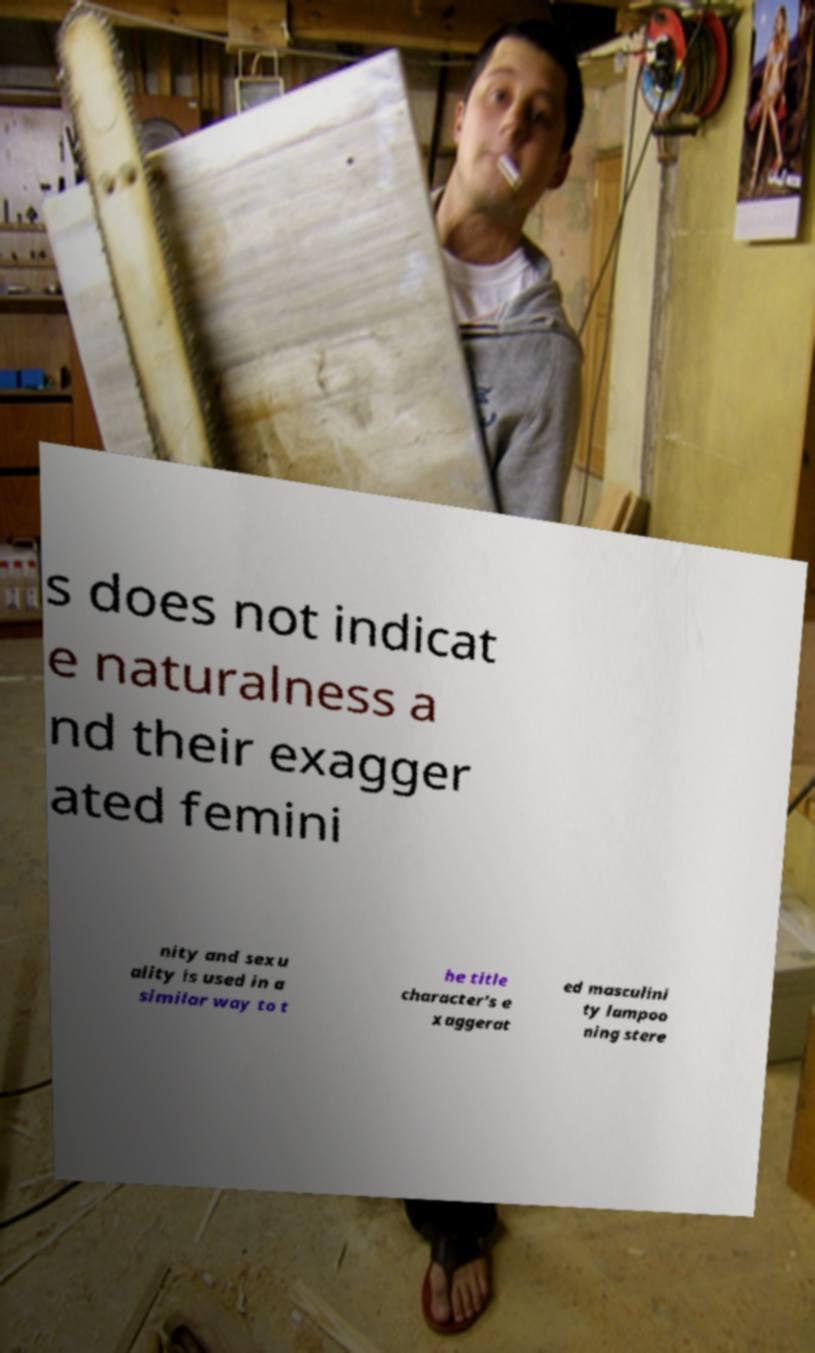I need the written content from this picture converted into text. Can you do that? s does not indicat e naturalness a nd their exagger ated femini nity and sexu ality is used in a similar way to t he title character's e xaggerat ed masculini ty lampoo ning stere 